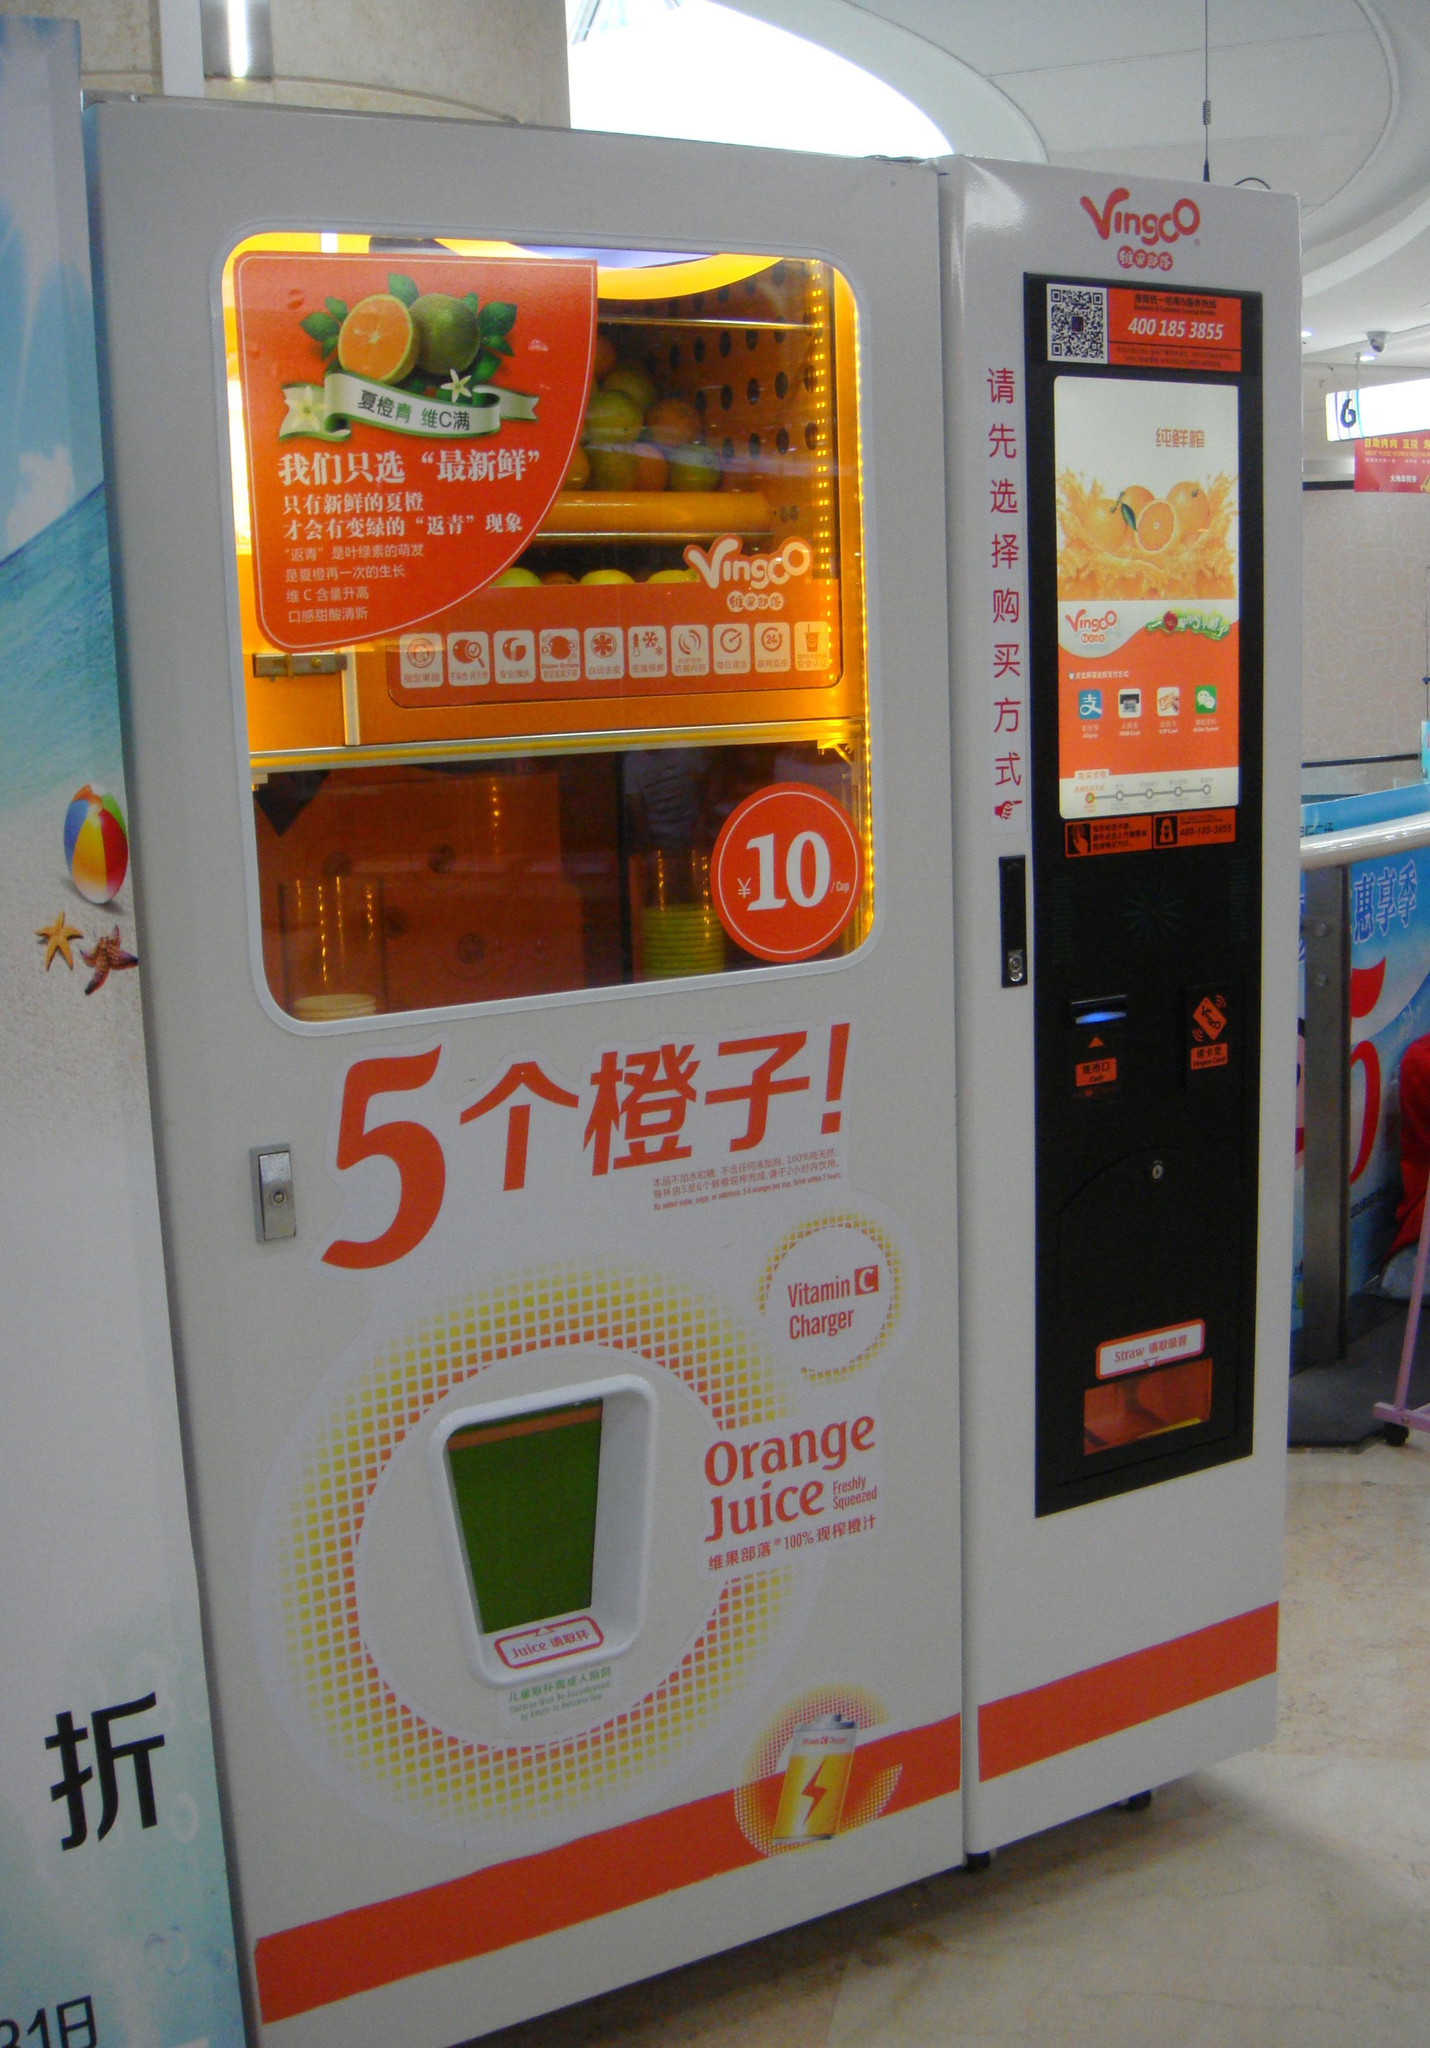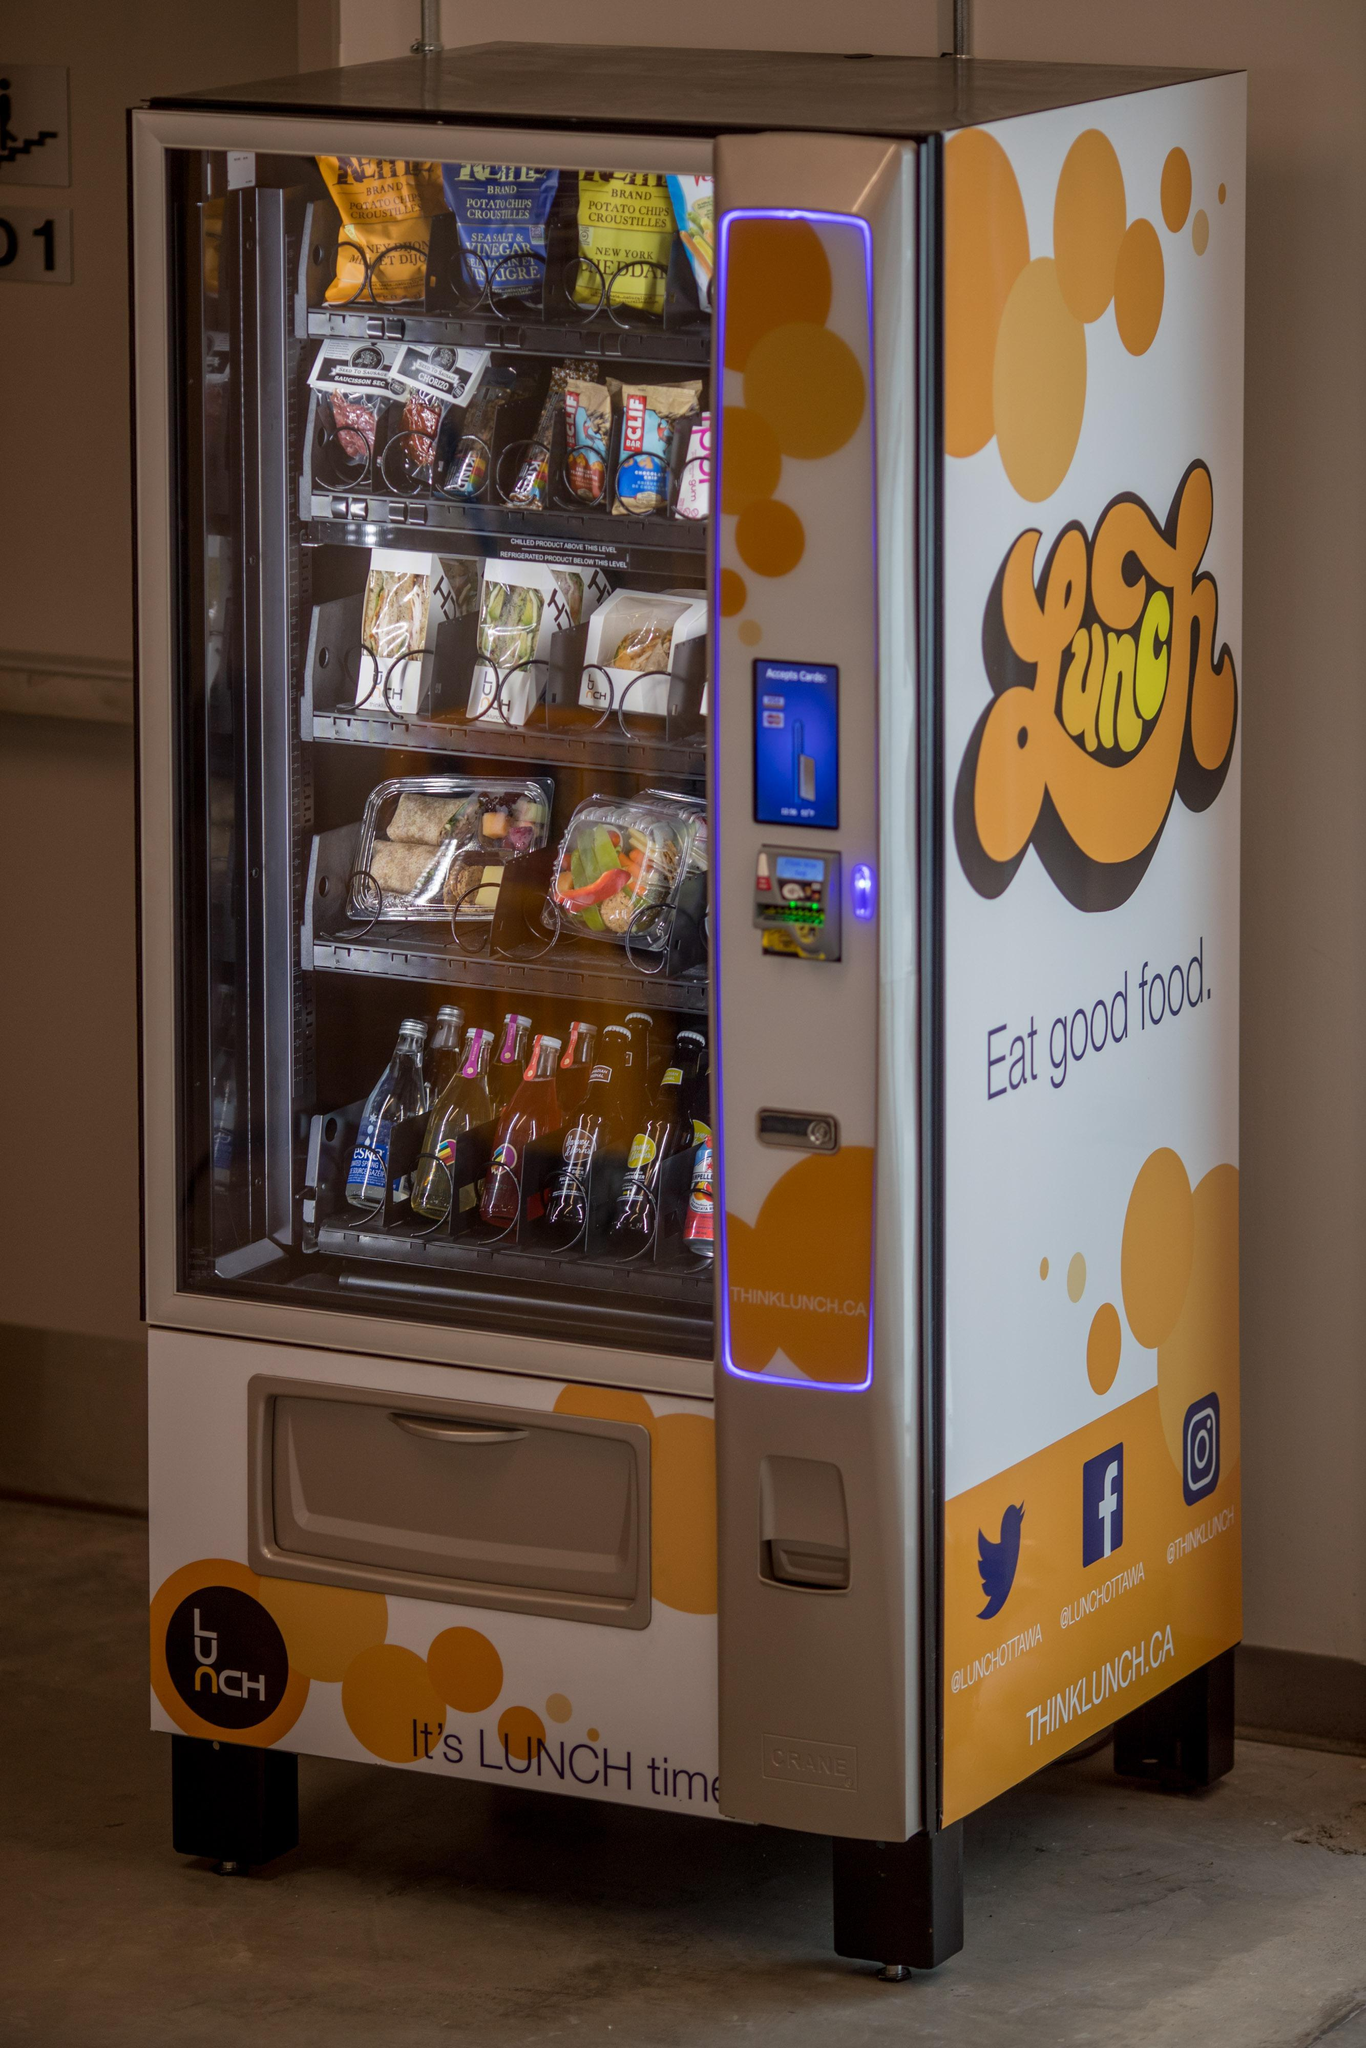The first image is the image on the left, the second image is the image on the right. For the images displayed, is the sentence "One image shows a horizontal row of exactly three vending machines, with none more than about a foot apart." factually correct? Answer yes or no. No. The first image is the image on the left, the second image is the image on the right. For the images shown, is this caption "In at least one of the images, at least three vending machines are shown in three unique colors including blue and red." true? Answer yes or no. No. 